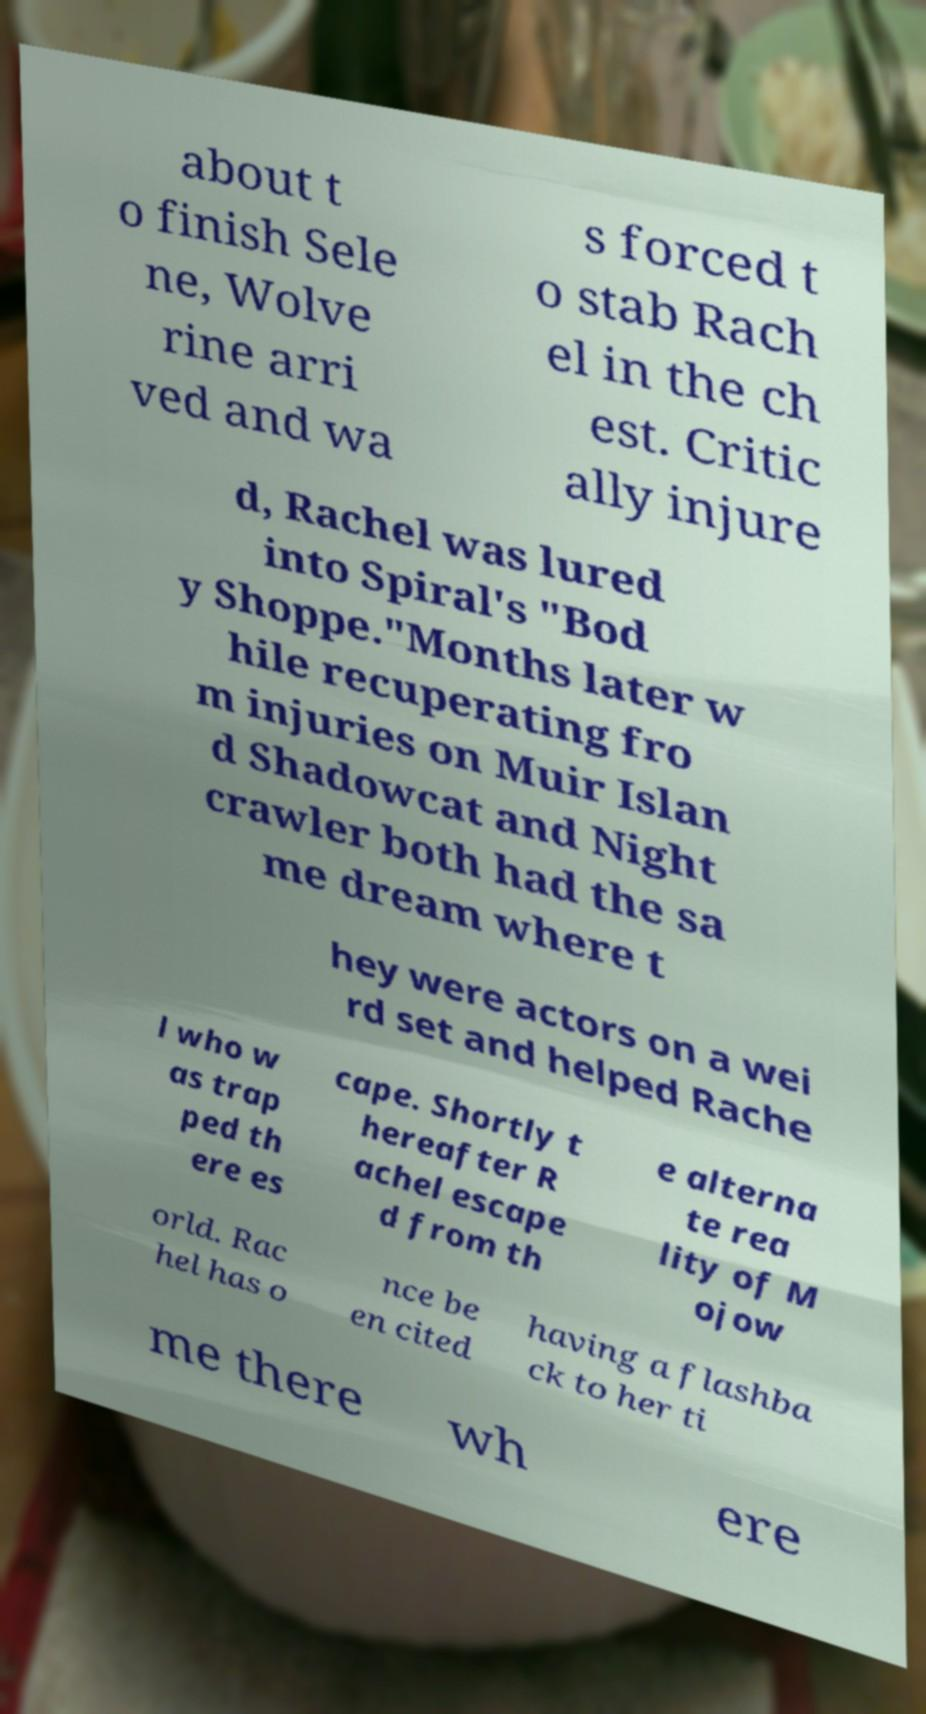For documentation purposes, I need the text within this image transcribed. Could you provide that? about t o finish Sele ne, Wolve rine arri ved and wa s forced t o stab Rach el in the ch est. Critic ally injure d, Rachel was lured into Spiral's "Bod y Shoppe."Months later w hile recuperating fro m injuries on Muir Islan d Shadowcat and Night crawler both had the sa me dream where t hey were actors on a wei rd set and helped Rache l who w as trap ped th ere es cape. Shortly t hereafter R achel escape d from th e alterna te rea lity of M ojow orld. Rac hel has o nce be en cited having a flashba ck to her ti me there wh ere 